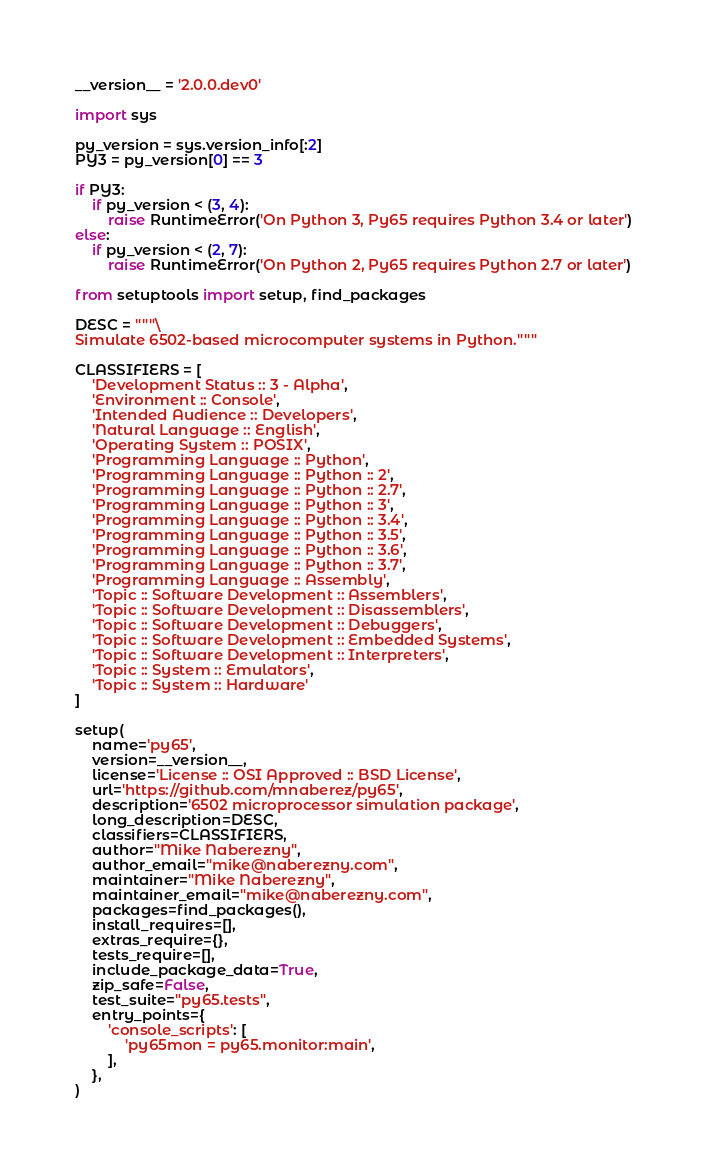Convert code to text. <code><loc_0><loc_0><loc_500><loc_500><_Python_>__version__ = '2.0.0.dev0'

import sys

py_version = sys.version_info[:2]
PY3 = py_version[0] == 3

if PY3:
    if py_version < (3, 4):
        raise RuntimeError('On Python 3, Py65 requires Python 3.4 or later')
else:
    if py_version < (2, 7):
        raise RuntimeError('On Python 2, Py65 requires Python 2.7 or later')

from setuptools import setup, find_packages

DESC = """\
Simulate 6502-based microcomputer systems in Python."""

CLASSIFIERS = [
    'Development Status :: 3 - Alpha',
    'Environment :: Console',
    'Intended Audience :: Developers',
    'Natural Language :: English',
    'Operating System :: POSIX',
    'Programming Language :: Python',
    'Programming Language :: Python :: 2',
    'Programming Language :: Python :: 2.7',
    'Programming Language :: Python :: 3',
    'Programming Language :: Python :: 3.4',
    'Programming Language :: Python :: 3.5',
    'Programming Language :: Python :: 3.6',
    'Programming Language :: Python :: 3.7',
    'Programming Language :: Assembly',
    'Topic :: Software Development :: Assemblers',
    'Topic :: Software Development :: Disassemblers',
    'Topic :: Software Development :: Debuggers',
    'Topic :: Software Development :: Embedded Systems',
    'Topic :: Software Development :: Interpreters',
    'Topic :: System :: Emulators',
    'Topic :: System :: Hardware'
]

setup(
    name='py65',
    version=__version__,
    license='License :: OSI Approved :: BSD License',
    url='https://github.com/mnaberez/py65',
    description='6502 microprocessor simulation package',
    long_description=DESC,
    classifiers=CLASSIFIERS,
    author="Mike Naberezny",
    author_email="mike@naberezny.com",
    maintainer="Mike Naberezny",
    maintainer_email="mike@naberezny.com",
    packages=find_packages(),
    install_requires=[],
    extras_require={},
    tests_require=[],
    include_package_data=True,
    zip_safe=False,
    test_suite="py65.tests",
    entry_points={
        'console_scripts': [
            'py65mon = py65.monitor:main',
        ],
    },
)
</code> 